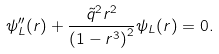Convert formula to latex. <formula><loc_0><loc_0><loc_500><loc_500>\psi _ { L } ^ { \prime \prime } ( r ) + \frac { \tilde { q } ^ { 2 } r ^ { 2 } } { \left ( 1 - r ^ { 3 } \right ) ^ { 2 } } \psi _ { L } ( r ) = 0 .</formula> 